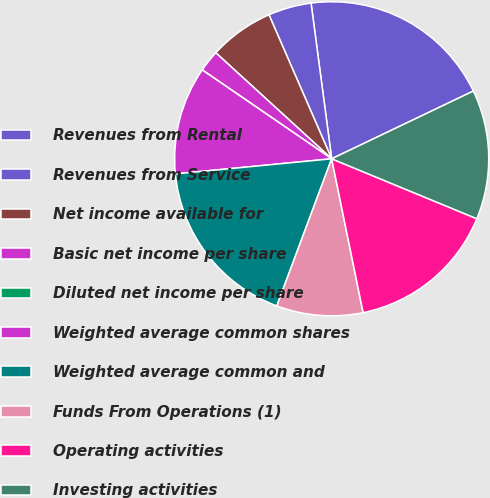Convert chart to OTSL. <chart><loc_0><loc_0><loc_500><loc_500><pie_chart><fcel>Revenues from Rental<fcel>Revenues from Service<fcel>Net income available for<fcel>Basic net income per share<fcel>Diluted net income per share<fcel>Weighted average common shares<fcel>Weighted average common and<fcel>Funds From Operations (1)<fcel>Operating activities<fcel>Investing activities<nl><fcel>20.0%<fcel>4.44%<fcel>6.67%<fcel>2.22%<fcel>0.0%<fcel>11.11%<fcel>17.78%<fcel>8.89%<fcel>15.56%<fcel>13.33%<nl></chart> 